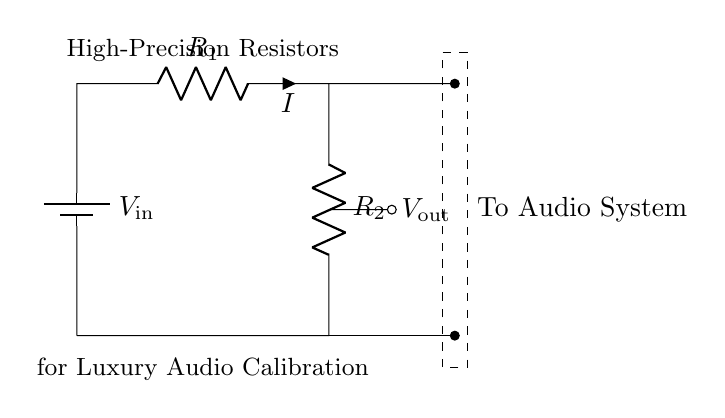What is the input voltage of the circuit? The input voltage, labeled as V_in, is the power supplied to the circuit. While the exact value is not specified visually, it's typically considered to be the voltage across the battery, which would be stated clearly if provided.
Answer: V_in What are the components labeled in this circuit? The circuit contains two resistors labeled R_1 and R_2, a battery (source) labeled V_in, and output voltage V_out. The resistors are part of the voltage divider configuration, and the battery is the power source.
Answer: R_1, R_2, V_in, V_out What is the current flowing through the first resistor? The current flowing through the first resistor R_1 is indicated by the label I. Since this is a voltage divider, the same current flows through both resistors in series. The current is defined as I in the circuit.
Answer: I What type of resistors are used in this circuit? The resistors in this circuit are specifically designated as "High-Precision Resistors", which implies they have a high level of accuracy and stability in their resistance values, suitable for calibration purposes.
Answer: High-Precision Resistors What is V_out's significance in this circuit? V_out represents the output voltage taken from the voltage divider and is determined by the ratio of the resistors R_1 and R_2. It is crucial in providing a precise voltage level for the audio system calibration.
Answer: Output voltage How does V_out relate to V_in in this voltage divider? V_out is related to V_in by the voltage divider formula: V_out = V_in * (R_2 / (R_1 + R_2)). This shows that V_out is a fraction of V_in, determined by the resistance values. This relationship is essential for achieving accurate calibration.
Answer: V_out = V_in * (R_2 / (R_1 + R_2)) 